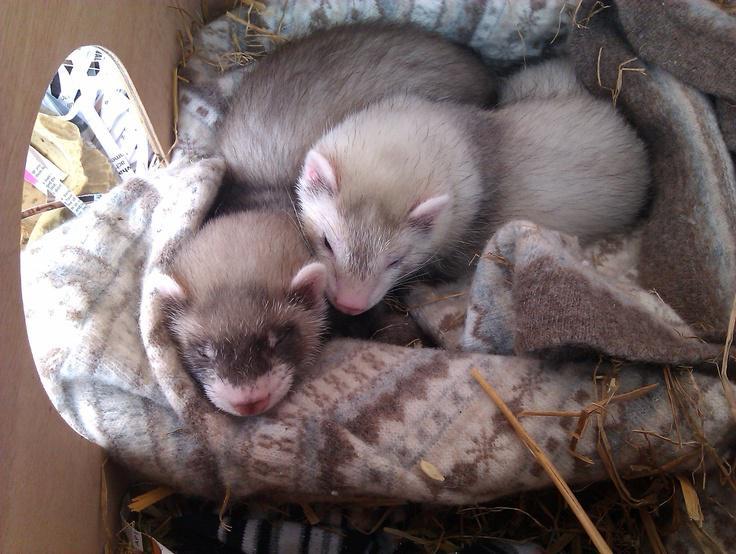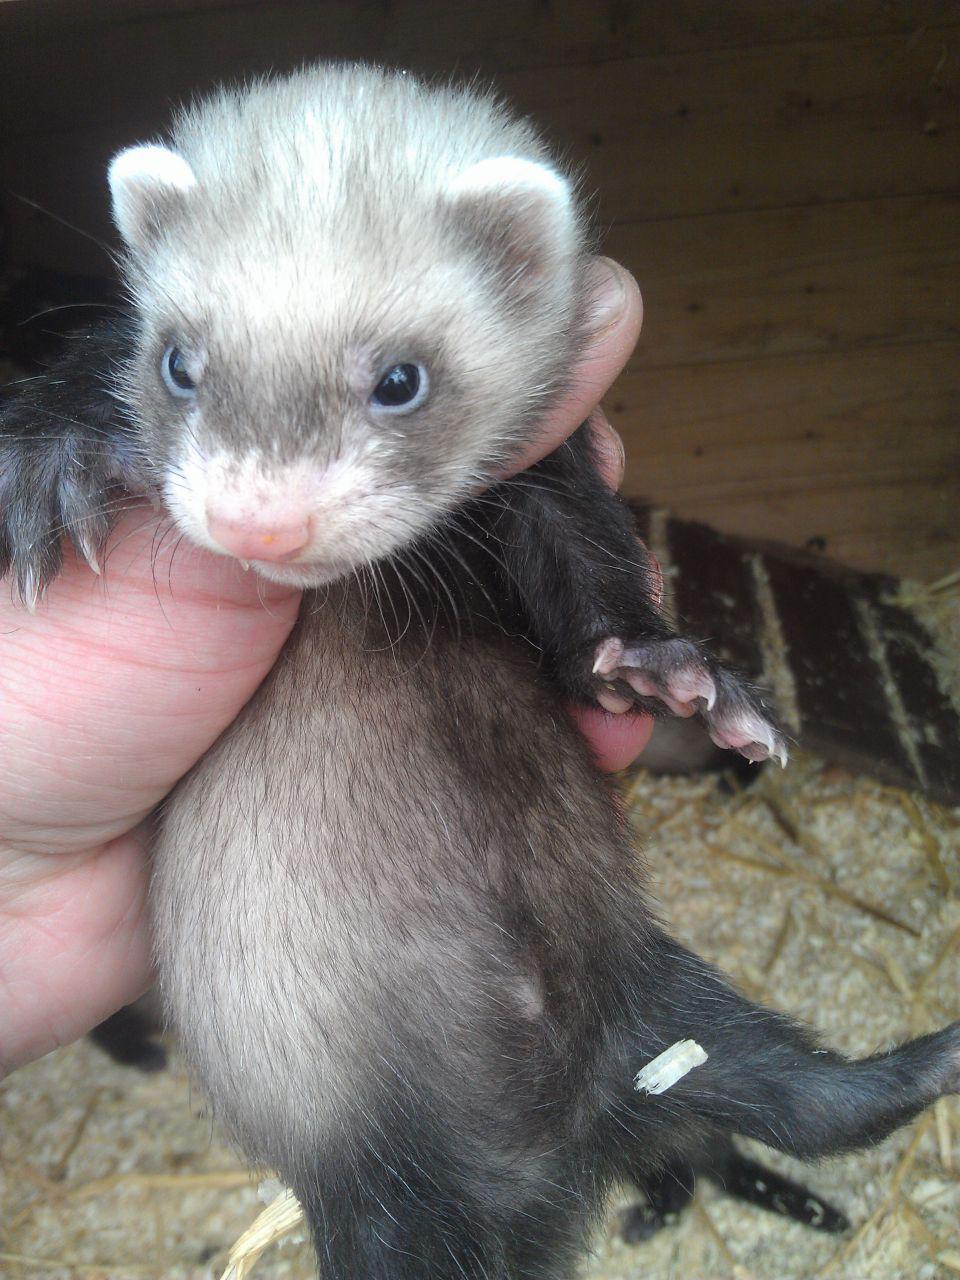The first image is the image on the left, the second image is the image on the right. Given the left and right images, does the statement "The right image contains exactly one ferret." hold true? Answer yes or no. Yes. The first image is the image on the left, the second image is the image on the right. Analyze the images presented: Is the assertion "Some ferrets are in a container." valid? Answer yes or no. Yes. 